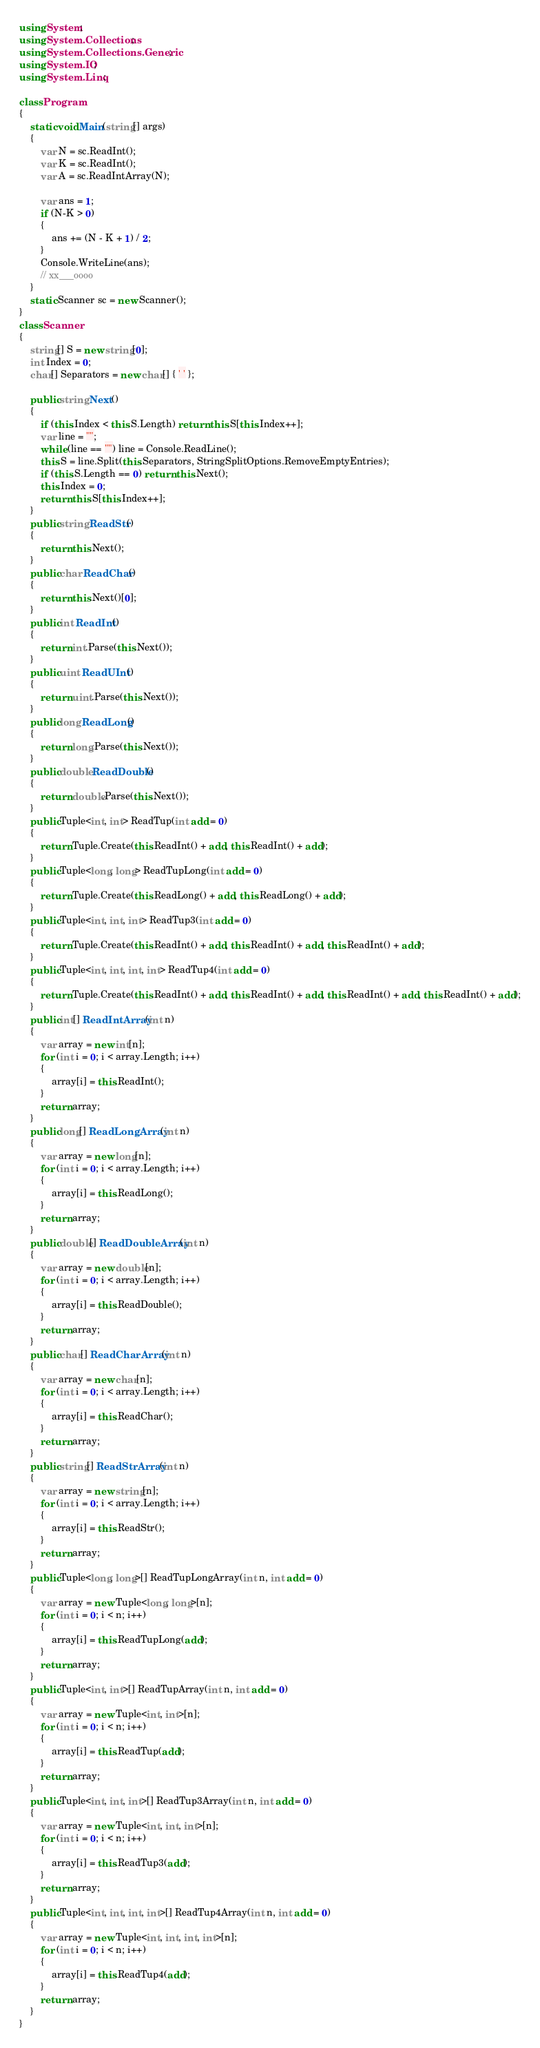<code> <loc_0><loc_0><loc_500><loc_500><_C#_>using System;
using System.Collections;
using System.Collections.Generic;
using System.IO;
using System.Linq;

class Program
{
    static void Main(string[] args)
    {
        var N = sc.ReadInt();
        var K = sc.ReadInt();
        var A = sc.ReadIntArray(N);

        var ans = 1;
        if (N-K > 0)
        {
            ans += (N - K + 1) / 2;
        }
        Console.WriteLine(ans);
        // xx___oooo
    }
    static Scanner sc = new Scanner();
}
class Scanner
{
    string[] S = new string[0];
    int Index = 0;
    char[] Separators = new char[] { ' ' };

    public string Next()
    {
        if (this.Index < this.S.Length) return this.S[this.Index++];
        var line = "";
        while (line == "") line = Console.ReadLine();
        this.S = line.Split(this.Separators, StringSplitOptions.RemoveEmptyEntries);
        if (this.S.Length == 0) return this.Next();
        this.Index = 0;
        return this.S[this.Index++];
    }
    public string ReadStr()
    {
        return this.Next();
    }
    public char ReadChar()
    {
        return this.Next()[0];
    }
    public int ReadInt()
    {
        return int.Parse(this.Next());
    }
    public uint ReadUInt()
    {
        return uint.Parse(this.Next());
    }
    public long ReadLong()
    {
        return long.Parse(this.Next());
    }
    public double ReadDouble()
    {
        return double.Parse(this.Next());
    }
    public Tuple<int, int> ReadTup(int add = 0)
    {
        return Tuple.Create(this.ReadInt() + add, this.ReadInt() + add);
    }
    public Tuple<long, long> ReadTupLong(int add = 0)
    {
        return Tuple.Create(this.ReadLong() + add, this.ReadLong() + add);
    }
    public Tuple<int, int, int> ReadTup3(int add = 0)
    {
        return Tuple.Create(this.ReadInt() + add, this.ReadInt() + add, this.ReadInt() + add);
    }
    public Tuple<int, int, int, int> ReadTup4(int add = 0)
    {
        return Tuple.Create(this.ReadInt() + add, this.ReadInt() + add, this.ReadInt() + add, this.ReadInt() + add);
    }
    public int[] ReadIntArray(int n)
    {
        var array = new int[n];
        for (int i = 0; i < array.Length; i++)
        {
            array[i] = this.ReadInt();
        }
        return array;
    }
    public long[] ReadLongArray(int n)
    {
        var array = new long[n];
        for (int i = 0; i < array.Length; i++)
        {
            array[i] = this.ReadLong();
        }
        return array;
    }
    public double[] ReadDoubleArray(int n)
    {
        var array = new double[n];
        for (int i = 0; i < array.Length; i++)
        {
            array[i] = this.ReadDouble();
        }
        return array;
    }
    public char[] ReadCharArray(int n)
    {
        var array = new char[n];
        for (int i = 0; i < array.Length; i++)
        {
            array[i] = this.ReadChar();
        }
        return array;
    }
    public string[] ReadStrArray(int n)
    {
        var array = new string[n];
        for (int i = 0; i < array.Length; i++)
        {
            array[i] = this.ReadStr();
        }
        return array;
    }
    public Tuple<long, long>[] ReadTupLongArray(int n, int add = 0)
    {
        var array = new Tuple<long, long>[n];
        for (int i = 0; i < n; i++)
        {
            array[i] = this.ReadTupLong(add);
        }
        return array;
    }
    public Tuple<int, int>[] ReadTupArray(int n, int add = 0)
    {
        var array = new Tuple<int, int>[n];
        for (int i = 0; i < n; i++)
        {
            array[i] = this.ReadTup(add);
        }
        return array;
    }
    public Tuple<int, int, int>[] ReadTup3Array(int n, int add = 0)
    {
        var array = new Tuple<int, int, int>[n];
        for (int i = 0; i < n; i++)
        {
            array[i] = this.ReadTup3(add);
        }
        return array;
    }
    public Tuple<int, int, int, int>[] ReadTup4Array(int n, int add = 0)
    {
        var array = new Tuple<int, int, int, int>[n];
        for (int i = 0; i < n; i++)
        {
            array[i] = this.ReadTup4(add);
        }
        return array;
    }
}
</code> 